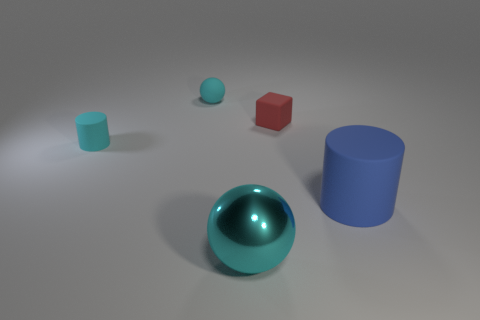What size is the cyan thing that is behind the small red object?
Ensure brevity in your answer.  Small. There is another sphere that is the same color as the large sphere; what is its material?
Your response must be concise. Rubber. The cube that is the same size as the cyan rubber ball is what color?
Ensure brevity in your answer.  Red. Does the red block have the same size as the blue cylinder?
Your response must be concise. No. There is a rubber thing that is behind the blue rubber object and to the right of the cyan rubber ball; what is its size?
Your response must be concise. Small. How many matte objects are either large gray things or cylinders?
Make the answer very short. 2. Is the number of big matte things left of the big rubber thing greater than the number of small matte cylinders?
Your response must be concise. No. There is a cylinder that is on the left side of the blue rubber thing; what material is it?
Make the answer very short. Rubber. How many large cyan things have the same material as the small red block?
Ensure brevity in your answer.  0. What shape is the rubber thing that is in front of the red block and to the right of the small cyan ball?
Provide a short and direct response. Cylinder. 